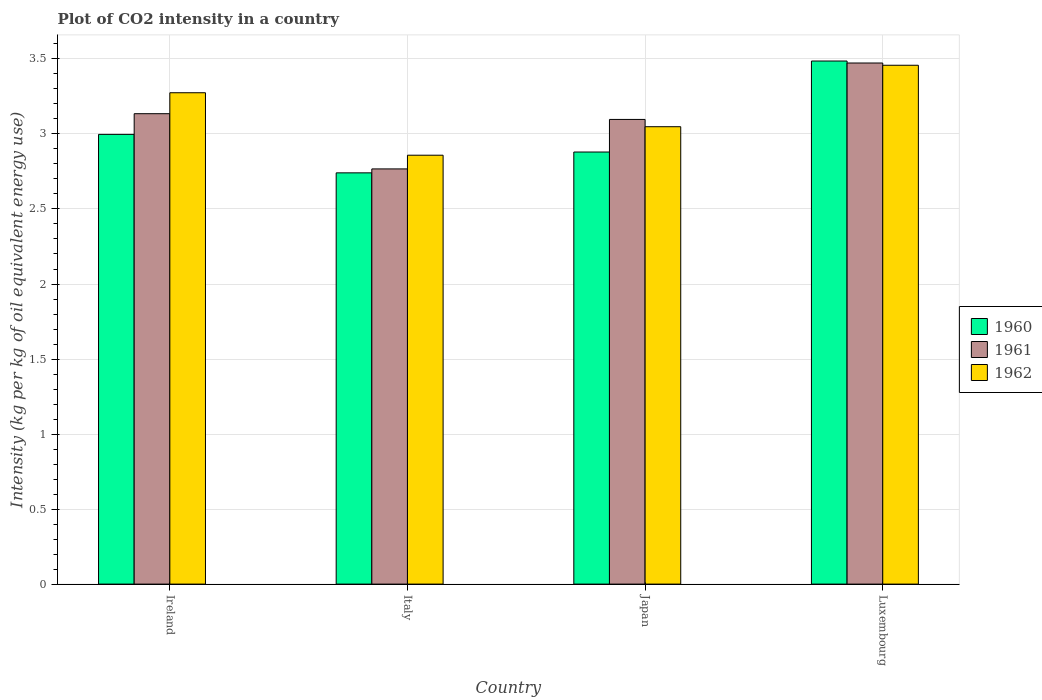How many bars are there on the 3rd tick from the left?
Make the answer very short. 3. How many bars are there on the 1st tick from the right?
Your answer should be very brief. 3. What is the label of the 1st group of bars from the left?
Offer a very short reply. Ireland. What is the CO2 intensity in in 1962 in Ireland?
Give a very brief answer. 3.27. Across all countries, what is the maximum CO2 intensity in in 1960?
Keep it short and to the point. 3.49. Across all countries, what is the minimum CO2 intensity in in 1961?
Provide a succinct answer. 2.77. In which country was the CO2 intensity in in 1962 maximum?
Your response must be concise. Luxembourg. What is the total CO2 intensity in in 1960 in the graph?
Your answer should be compact. 12.1. What is the difference between the CO2 intensity in in 1961 in Ireland and that in Luxembourg?
Offer a terse response. -0.34. What is the difference between the CO2 intensity in in 1962 in Luxembourg and the CO2 intensity in in 1960 in Japan?
Provide a short and direct response. 0.58. What is the average CO2 intensity in in 1960 per country?
Your answer should be compact. 3.03. What is the difference between the CO2 intensity in of/in 1960 and CO2 intensity in of/in 1961 in Ireland?
Give a very brief answer. -0.14. In how many countries, is the CO2 intensity in in 1960 greater than 1 kg?
Offer a terse response. 4. What is the ratio of the CO2 intensity in in 1962 in Italy to that in Japan?
Keep it short and to the point. 0.94. Is the CO2 intensity in in 1962 in Italy less than that in Luxembourg?
Provide a short and direct response. Yes. What is the difference between the highest and the second highest CO2 intensity in in 1960?
Offer a very short reply. -0.49. What is the difference between the highest and the lowest CO2 intensity in in 1960?
Keep it short and to the point. 0.75. In how many countries, is the CO2 intensity in in 1961 greater than the average CO2 intensity in in 1961 taken over all countries?
Offer a terse response. 2. Is the sum of the CO2 intensity in in 1960 in Ireland and Luxembourg greater than the maximum CO2 intensity in in 1961 across all countries?
Your answer should be compact. Yes. What does the 1st bar from the right in Italy represents?
Give a very brief answer. 1962. Is it the case that in every country, the sum of the CO2 intensity in in 1961 and CO2 intensity in in 1960 is greater than the CO2 intensity in in 1962?
Provide a succinct answer. Yes. Are all the bars in the graph horizontal?
Keep it short and to the point. No. What is the difference between two consecutive major ticks on the Y-axis?
Your answer should be compact. 0.5. Are the values on the major ticks of Y-axis written in scientific E-notation?
Make the answer very short. No. Where does the legend appear in the graph?
Your answer should be compact. Center right. How are the legend labels stacked?
Offer a very short reply. Vertical. What is the title of the graph?
Offer a very short reply. Plot of CO2 intensity in a country. Does "1979" appear as one of the legend labels in the graph?
Make the answer very short. No. What is the label or title of the X-axis?
Offer a very short reply. Country. What is the label or title of the Y-axis?
Your answer should be very brief. Intensity (kg per kg of oil equivalent energy use). What is the Intensity (kg per kg of oil equivalent energy use) in 1960 in Ireland?
Give a very brief answer. 3. What is the Intensity (kg per kg of oil equivalent energy use) of 1961 in Ireland?
Provide a succinct answer. 3.14. What is the Intensity (kg per kg of oil equivalent energy use) in 1962 in Ireland?
Provide a short and direct response. 3.27. What is the Intensity (kg per kg of oil equivalent energy use) of 1960 in Italy?
Make the answer very short. 2.74. What is the Intensity (kg per kg of oil equivalent energy use) in 1961 in Italy?
Offer a terse response. 2.77. What is the Intensity (kg per kg of oil equivalent energy use) of 1962 in Italy?
Ensure brevity in your answer.  2.86. What is the Intensity (kg per kg of oil equivalent energy use) of 1960 in Japan?
Your response must be concise. 2.88. What is the Intensity (kg per kg of oil equivalent energy use) of 1961 in Japan?
Provide a succinct answer. 3.1. What is the Intensity (kg per kg of oil equivalent energy use) of 1962 in Japan?
Provide a short and direct response. 3.05. What is the Intensity (kg per kg of oil equivalent energy use) of 1960 in Luxembourg?
Your answer should be very brief. 3.49. What is the Intensity (kg per kg of oil equivalent energy use) of 1961 in Luxembourg?
Give a very brief answer. 3.47. What is the Intensity (kg per kg of oil equivalent energy use) of 1962 in Luxembourg?
Your response must be concise. 3.46. Across all countries, what is the maximum Intensity (kg per kg of oil equivalent energy use) of 1960?
Make the answer very short. 3.49. Across all countries, what is the maximum Intensity (kg per kg of oil equivalent energy use) of 1961?
Your response must be concise. 3.47. Across all countries, what is the maximum Intensity (kg per kg of oil equivalent energy use) in 1962?
Offer a terse response. 3.46. Across all countries, what is the minimum Intensity (kg per kg of oil equivalent energy use) of 1960?
Provide a succinct answer. 2.74. Across all countries, what is the minimum Intensity (kg per kg of oil equivalent energy use) of 1961?
Your answer should be compact. 2.77. Across all countries, what is the minimum Intensity (kg per kg of oil equivalent energy use) of 1962?
Offer a very short reply. 2.86. What is the total Intensity (kg per kg of oil equivalent energy use) of 1960 in the graph?
Provide a succinct answer. 12.1. What is the total Intensity (kg per kg of oil equivalent energy use) of 1961 in the graph?
Provide a succinct answer. 12.47. What is the total Intensity (kg per kg of oil equivalent energy use) of 1962 in the graph?
Make the answer very short. 12.64. What is the difference between the Intensity (kg per kg of oil equivalent energy use) of 1960 in Ireland and that in Italy?
Give a very brief answer. 0.26. What is the difference between the Intensity (kg per kg of oil equivalent energy use) in 1961 in Ireland and that in Italy?
Give a very brief answer. 0.37. What is the difference between the Intensity (kg per kg of oil equivalent energy use) of 1962 in Ireland and that in Italy?
Your answer should be very brief. 0.42. What is the difference between the Intensity (kg per kg of oil equivalent energy use) in 1960 in Ireland and that in Japan?
Ensure brevity in your answer.  0.12. What is the difference between the Intensity (kg per kg of oil equivalent energy use) of 1961 in Ireland and that in Japan?
Ensure brevity in your answer.  0.04. What is the difference between the Intensity (kg per kg of oil equivalent energy use) of 1962 in Ireland and that in Japan?
Provide a short and direct response. 0.23. What is the difference between the Intensity (kg per kg of oil equivalent energy use) in 1960 in Ireland and that in Luxembourg?
Keep it short and to the point. -0.49. What is the difference between the Intensity (kg per kg of oil equivalent energy use) of 1961 in Ireland and that in Luxembourg?
Your response must be concise. -0.34. What is the difference between the Intensity (kg per kg of oil equivalent energy use) in 1962 in Ireland and that in Luxembourg?
Your answer should be very brief. -0.18. What is the difference between the Intensity (kg per kg of oil equivalent energy use) of 1960 in Italy and that in Japan?
Your response must be concise. -0.14. What is the difference between the Intensity (kg per kg of oil equivalent energy use) in 1961 in Italy and that in Japan?
Provide a succinct answer. -0.33. What is the difference between the Intensity (kg per kg of oil equivalent energy use) of 1962 in Italy and that in Japan?
Your answer should be very brief. -0.19. What is the difference between the Intensity (kg per kg of oil equivalent energy use) of 1960 in Italy and that in Luxembourg?
Provide a succinct answer. -0.75. What is the difference between the Intensity (kg per kg of oil equivalent energy use) of 1961 in Italy and that in Luxembourg?
Make the answer very short. -0.71. What is the difference between the Intensity (kg per kg of oil equivalent energy use) of 1962 in Italy and that in Luxembourg?
Offer a terse response. -0.6. What is the difference between the Intensity (kg per kg of oil equivalent energy use) in 1960 in Japan and that in Luxembourg?
Keep it short and to the point. -0.61. What is the difference between the Intensity (kg per kg of oil equivalent energy use) of 1961 in Japan and that in Luxembourg?
Give a very brief answer. -0.38. What is the difference between the Intensity (kg per kg of oil equivalent energy use) of 1962 in Japan and that in Luxembourg?
Give a very brief answer. -0.41. What is the difference between the Intensity (kg per kg of oil equivalent energy use) of 1960 in Ireland and the Intensity (kg per kg of oil equivalent energy use) of 1961 in Italy?
Offer a terse response. 0.23. What is the difference between the Intensity (kg per kg of oil equivalent energy use) of 1960 in Ireland and the Intensity (kg per kg of oil equivalent energy use) of 1962 in Italy?
Keep it short and to the point. 0.14. What is the difference between the Intensity (kg per kg of oil equivalent energy use) of 1961 in Ireland and the Intensity (kg per kg of oil equivalent energy use) of 1962 in Italy?
Give a very brief answer. 0.28. What is the difference between the Intensity (kg per kg of oil equivalent energy use) in 1960 in Ireland and the Intensity (kg per kg of oil equivalent energy use) in 1961 in Japan?
Make the answer very short. -0.1. What is the difference between the Intensity (kg per kg of oil equivalent energy use) in 1960 in Ireland and the Intensity (kg per kg of oil equivalent energy use) in 1962 in Japan?
Give a very brief answer. -0.05. What is the difference between the Intensity (kg per kg of oil equivalent energy use) of 1961 in Ireland and the Intensity (kg per kg of oil equivalent energy use) of 1962 in Japan?
Provide a succinct answer. 0.09. What is the difference between the Intensity (kg per kg of oil equivalent energy use) of 1960 in Ireland and the Intensity (kg per kg of oil equivalent energy use) of 1961 in Luxembourg?
Make the answer very short. -0.48. What is the difference between the Intensity (kg per kg of oil equivalent energy use) in 1960 in Ireland and the Intensity (kg per kg of oil equivalent energy use) in 1962 in Luxembourg?
Give a very brief answer. -0.46. What is the difference between the Intensity (kg per kg of oil equivalent energy use) in 1961 in Ireland and the Intensity (kg per kg of oil equivalent energy use) in 1962 in Luxembourg?
Offer a very short reply. -0.32. What is the difference between the Intensity (kg per kg of oil equivalent energy use) of 1960 in Italy and the Intensity (kg per kg of oil equivalent energy use) of 1961 in Japan?
Your answer should be compact. -0.36. What is the difference between the Intensity (kg per kg of oil equivalent energy use) in 1960 in Italy and the Intensity (kg per kg of oil equivalent energy use) in 1962 in Japan?
Provide a succinct answer. -0.31. What is the difference between the Intensity (kg per kg of oil equivalent energy use) in 1961 in Italy and the Intensity (kg per kg of oil equivalent energy use) in 1962 in Japan?
Provide a succinct answer. -0.28. What is the difference between the Intensity (kg per kg of oil equivalent energy use) in 1960 in Italy and the Intensity (kg per kg of oil equivalent energy use) in 1961 in Luxembourg?
Your answer should be compact. -0.73. What is the difference between the Intensity (kg per kg of oil equivalent energy use) of 1960 in Italy and the Intensity (kg per kg of oil equivalent energy use) of 1962 in Luxembourg?
Offer a very short reply. -0.72. What is the difference between the Intensity (kg per kg of oil equivalent energy use) in 1961 in Italy and the Intensity (kg per kg of oil equivalent energy use) in 1962 in Luxembourg?
Offer a terse response. -0.69. What is the difference between the Intensity (kg per kg of oil equivalent energy use) of 1960 in Japan and the Intensity (kg per kg of oil equivalent energy use) of 1961 in Luxembourg?
Your answer should be very brief. -0.59. What is the difference between the Intensity (kg per kg of oil equivalent energy use) of 1960 in Japan and the Intensity (kg per kg of oil equivalent energy use) of 1962 in Luxembourg?
Offer a terse response. -0.58. What is the difference between the Intensity (kg per kg of oil equivalent energy use) in 1961 in Japan and the Intensity (kg per kg of oil equivalent energy use) in 1962 in Luxembourg?
Your answer should be very brief. -0.36. What is the average Intensity (kg per kg of oil equivalent energy use) of 1960 per country?
Make the answer very short. 3.03. What is the average Intensity (kg per kg of oil equivalent energy use) in 1961 per country?
Make the answer very short. 3.12. What is the average Intensity (kg per kg of oil equivalent energy use) of 1962 per country?
Provide a succinct answer. 3.16. What is the difference between the Intensity (kg per kg of oil equivalent energy use) of 1960 and Intensity (kg per kg of oil equivalent energy use) of 1961 in Ireland?
Provide a short and direct response. -0.14. What is the difference between the Intensity (kg per kg of oil equivalent energy use) in 1960 and Intensity (kg per kg of oil equivalent energy use) in 1962 in Ireland?
Provide a short and direct response. -0.28. What is the difference between the Intensity (kg per kg of oil equivalent energy use) of 1961 and Intensity (kg per kg of oil equivalent energy use) of 1962 in Ireland?
Offer a terse response. -0.14. What is the difference between the Intensity (kg per kg of oil equivalent energy use) in 1960 and Intensity (kg per kg of oil equivalent energy use) in 1961 in Italy?
Your answer should be very brief. -0.03. What is the difference between the Intensity (kg per kg of oil equivalent energy use) in 1960 and Intensity (kg per kg of oil equivalent energy use) in 1962 in Italy?
Provide a short and direct response. -0.12. What is the difference between the Intensity (kg per kg of oil equivalent energy use) in 1961 and Intensity (kg per kg of oil equivalent energy use) in 1962 in Italy?
Provide a short and direct response. -0.09. What is the difference between the Intensity (kg per kg of oil equivalent energy use) in 1960 and Intensity (kg per kg of oil equivalent energy use) in 1961 in Japan?
Offer a very short reply. -0.22. What is the difference between the Intensity (kg per kg of oil equivalent energy use) in 1960 and Intensity (kg per kg of oil equivalent energy use) in 1962 in Japan?
Provide a succinct answer. -0.17. What is the difference between the Intensity (kg per kg of oil equivalent energy use) of 1961 and Intensity (kg per kg of oil equivalent energy use) of 1962 in Japan?
Provide a short and direct response. 0.05. What is the difference between the Intensity (kg per kg of oil equivalent energy use) of 1960 and Intensity (kg per kg of oil equivalent energy use) of 1961 in Luxembourg?
Provide a short and direct response. 0.01. What is the difference between the Intensity (kg per kg of oil equivalent energy use) of 1960 and Intensity (kg per kg of oil equivalent energy use) of 1962 in Luxembourg?
Offer a terse response. 0.03. What is the difference between the Intensity (kg per kg of oil equivalent energy use) in 1961 and Intensity (kg per kg of oil equivalent energy use) in 1962 in Luxembourg?
Offer a very short reply. 0.01. What is the ratio of the Intensity (kg per kg of oil equivalent energy use) in 1960 in Ireland to that in Italy?
Your response must be concise. 1.09. What is the ratio of the Intensity (kg per kg of oil equivalent energy use) of 1961 in Ireland to that in Italy?
Offer a terse response. 1.13. What is the ratio of the Intensity (kg per kg of oil equivalent energy use) in 1962 in Ireland to that in Italy?
Provide a short and direct response. 1.15. What is the ratio of the Intensity (kg per kg of oil equivalent energy use) in 1960 in Ireland to that in Japan?
Give a very brief answer. 1.04. What is the ratio of the Intensity (kg per kg of oil equivalent energy use) in 1961 in Ireland to that in Japan?
Ensure brevity in your answer.  1.01. What is the ratio of the Intensity (kg per kg of oil equivalent energy use) in 1962 in Ireland to that in Japan?
Keep it short and to the point. 1.07. What is the ratio of the Intensity (kg per kg of oil equivalent energy use) of 1960 in Ireland to that in Luxembourg?
Offer a very short reply. 0.86. What is the ratio of the Intensity (kg per kg of oil equivalent energy use) of 1961 in Ireland to that in Luxembourg?
Provide a succinct answer. 0.9. What is the ratio of the Intensity (kg per kg of oil equivalent energy use) in 1962 in Ireland to that in Luxembourg?
Provide a short and direct response. 0.95. What is the ratio of the Intensity (kg per kg of oil equivalent energy use) in 1960 in Italy to that in Japan?
Ensure brevity in your answer.  0.95. What is the ratio of the Intensity (kg per kg of oil equivalent energy use) in 1961 in Italy to that in Japan?
Make the answer very short. 0.89. What is the ratio of the Intensity (kg per kg of oil equivalent energy use) of 1962 in Italy to that in Japan?
Provide a short and direct response. 0.94. What is the ratio of the Intensity (kg per kg of oil equivalent energy use) of 1960 in Italy to that in Luxembourg?
Make the answer very short. 0.79. What is the ratio of the Intensity (kg per kg of oil equivalent energy use) of 1961 in Italy to that in Luxembourg?
Provide a succinct answer. 0.8. What is the ratio of the Intensity (kg per kg of oil equivalent energy use) of 1962 in Italy to that in Luxembourg?
Provide a short and direct response. 0.83. What is the ratio of the Intensity (kg per kg of oil equivalent energy use) of 1960 in Japan to that in Luxembourg?
Your answer should be compact. 0.83. What is the ratio of the Intensity (kg per kg of oil equivalent energy use) of 1961 in Japan to that in Luxembourg?
Your answer should be very brief. 0.89. What is the ratio of the Intensity (kg per kg of oil equivalent energy use) in 1962 in Japan to that in Luxembourg?
Offer a terse response. 0.88. What is the difference between the highest and the second highest Intensity (kg per kg of oil equivalent energy use) of 1960?
Ensure brevity in your answer.  0.49. What is the difference between the highest and the second highest Intensity (kg per kg of oil equivalent energy use) of 1961?
Keep it short and to the point. 0.34. What is the difference between the highest and the second highest Intensity (kg per kg of oil equivalent energy use) of 1962?
Keep it short and to the point. 0.18. What is the difference between the highest and the lowest Intensity (kg per kg of oil equivalent energy use) of 1960?
Your response must be concise. 0.75. What is the difference between the highest and the lowest Intensity (kg per kg of oil equivalent energy use) of 1961?
Your answer should be compact. 0.71. What is the difference between the highest and the lowest Intensity (kg per kg of oil equivalent energy use) in 1962?
Give a very brief answer. 0.6. 